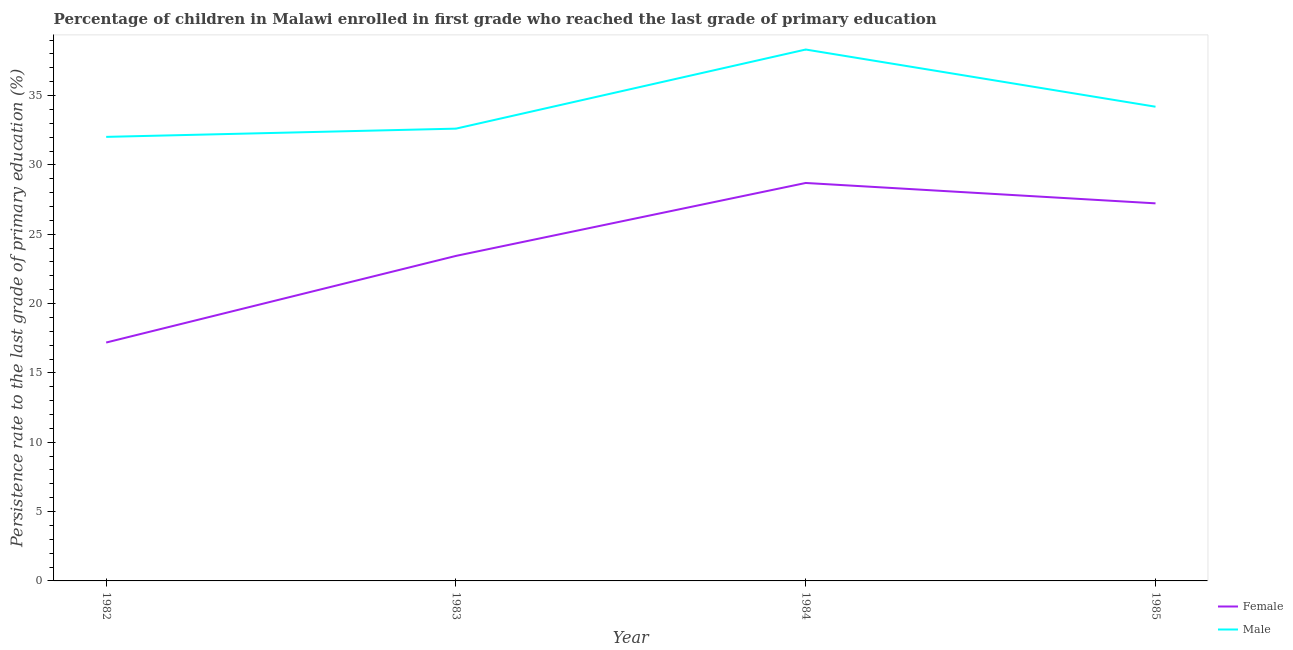Does the line corresponding to persistence rate of male students intersect with the line corresponding to persistence rate of female students?
Your response must be concise. No. Is the number of lines equal to the number of legend labels?
Offer a terse response. Yes. What is the persistence rate of female students in 1982?
Provide a succinct answer. 17.19. Across all years, what is the maximum persistence rate of male students?
Keep it short and to the point. 38.32. Across all years, what is the minimum persistence rate of female students?
Offer a very short reply. 17.19. In which year was the persistence rate of female students minimum?
Give a very brief answer. 1982. What is the total persistence rate of male students in the graph?
Your response must be concise. 137.15. What is the difference between the persistence rate of female students in 1982 and that in 1984?
Make the answer very short. -11.51. What is the difference between the persistence rate of female students in 1982 and the persistence rate of male students in 1984?
Make the answer very short. -21.13. What is the average persistence rate of female students per year?
Provide a short and direct response. 24.14. In the year 1983, what is the difference between the persistence rate of male students and persistence rate of female students?
Your response must be concise. 9.18. In how many years, is the persistence rate of male students greater than 19 %?
Give a very brief answer. 4. What is the ratio of the persistence rate of male students in 1983 to that in 1985?
Provide a short and direct response. 0.95. Is the persistence rate of female students in 1983 less than that in 1985?
Your response must be concise. Yes. Is the difference between the persistence rate of female students in 1984 and 1985 greater than the difference between the persistence rate of male students in 1984 and 1985?
Ensure brevity in your answer.  No. What is the difference between the highest and the second highest persistence rate of female students?
Ensure brevity in your answer.  1.47. What is the difference between the highest and the lowest persistence rate of female students?
Make the answer very short. 11.51. Is the sum of the persistence rate of female students in 1982 and 1985 greater than the maximum persistence rate of male students across all years?
Your response must be concise. Yes. How many years are there in the graph?
Ensure brevity in your answer.  4. What is the difference between two consecutive major ticks on the Y-axis?
Your answer should be compact. 5. Are the values on the major ticks of Y-axis written in scientific E-notation?
Give a very brief answer. No. Does the graph contain any zero values?
Keep it short and to the point. No. Does the graph contain grids?
Your response must be concise. No. How many legend labels are there?
Give a very brief answer. 2. How are the legend labels stacked?
Offer a terse response. Vertical. What is the title of the graph?
Provide a short and direct response. Percentage of children in Malawi enrolled in first grade who reached the last grade of primary education. Does "Current education expenditure" appear as one of the legend labels in the graph?
Keep it short and to the point. No. What is the label or title of the Y-axis?
Make the answer very short. Persistence rate to the last grade of primary education (%). What is the Persistence rate to the last grade of primary education (%) of Female in 1982?
Your answer should be very brief. 17.19. What is the Persistence rate to the last grade of primary education (%) of Male in 1982?
Your answer should be very brief. 32.02. What is the Persistence rate to the last grade of primary education (%) in Female in 1983?
Ensure brevity in your answer.  23.44. What is the Persistence rate to the last grade of primary education (%) in Male in 1983?
Give a very brief answer. 32.62. What is the Persistence rate to the last grade of primary education (%) in Female in 1984?
Give a very brief answer. 28.7. What is the Persistence rate to the last grade of primary education (%) in Male in 1984?
Provide a succinct answer. 38.32. What is the Persistence rate to the last grade of primary education (%) of Female in 1985?
Your answer should be compact. 27.23. What is the Persistence rate to the last grade of primary education (%) in Male in 1985?
Provide a succinct answer. 34.2. Across all years, what is the maximum Persistence rate to the last grade of primary education (%) of Female?
Your response must be concise. 28.7. Across all years, what is the maximum Persistence rate to the last grade of primary education (%) in Male?
Provide a short and direct response. 38.32. Across all years, what is the minimum Persistence rate to the last grade of primary education (%) in Female?
Provide a short and direct response. 17.19. Across all years, what is the minimum Persistence rate to the last grade of primary education (%) in Male?
Offer a terse response. 32.02. What is the total Persistence rate to the last grade of primary education (%) of Female in the graph?
Offer a very short reply. 96.55. What is the total Persistence rate to the last grade of primary education (%) in Male in the graph?
Offer a terse response. 137.15. What is the difference between the Persistence rate to the last grade of primary education (%) in Female in 1982 and that in 1983?
Make the answer very short. -6.25. What is the difference between the Persistence rate to the last grade of primary education (%) in Male in 1982 and that in 1983?
Make the answer very short. -0.59. What is the difference between the Persistence rate to the last grade of primary education (%) of Female in 1982 and that in 1984?
Your answer should be compact. -11.51. What is the difference between the Persistence rate to the last grade of primary education (%) of Male in 1982 and that in 1984?
Your answer should be very brief. -6.3. What is the difference between the Persistence rate to the last grade of primary education (%) of Female in 1982 and that in 1985?
Provide a succinct answer. -10.04. What is the difference between the Persistence rate to the last grade of primary education (%) in Male in 1982 and that in 1985?
Ensure brevity in your answer.  -2.17. What is the difference between the Persistence rate to the last grade of primary education (%) of Female in 1983 and that in 1984?
Keep it short and to the point. -5.26. What is the difference between the Persistence rate to the last grade of primary education (%) in Male in 1983 and that in 1984?
Your answer should be very brief. -5.71. What is the difference between the Persistence rate to the last grade of primary education (%) in Female in 1983 and that in 1985?
Your response must be concise. -3.79. What is the difference between the Persistence rate to the last grade of primary education (%) in Male in 1983 and that in 1985?
Your answer should be compact. -1.58. What is the difference between the Persistence rate to the last grade of primary education (%) in Female in 1984 and that in 1985?
Keep it short and to the point. 1.47. What is the difference between the Persistence rate to the last grade of primary education (%) of Male in 1984 and that in 1985?
Offer a terse response. 4.12. What is the difference between the Persistence rate to the last grade of primary education (%) in Female in 1982 and the Persistence rate to the last grade of primary education (%) in Male in 1983?
Keep it short and to the point. -15.42. What is the difference between the Persistence rate to the last grade of primary education (%) in Female in 1982 and the Persistence rate to the last grade of primary education (%) in Male in 1984?
Your response must be concise. -21.13. What is the difference between the Persistence rate to the last grade of primary education (%) of Female in 1982 and the Persistence rate to the last grade of primary education (%) of Male in 1985?
Make the answer very short. -17. What is the difference between the Persistence rate to the last grade of primary education (%) in Female in 1983 and the Persistence rate to the last grade of primary education (%) in Male in 1984?
Provide a short and direct response. -14.88. What is the difference between the Persistence rate to the last grade of primary education (%) of Female in 1983 and the Persistence rate to the last grade of primary education (%) of Male in 1985?
Your answer should be compact. -10.76. What is the difference between the Persistence rate to the last grade of primary education (%) of Female in 1984 and the Persistence rate to the last grade of primary education (%) of Male in 1985?
Offer a very short reply. -5.5. What is the average Persistence rate to the last grade of primary education (%) in Female per year?
Give a very brief answer. 24.14. What is the average Persistence rate to the last grade of primary education (%) of Male per year?
Provide a short and direct response. 34.29. In the year 1982, what is the difference between the Persistence rate to the last grade of primary education (%) of Female and Persistence rate to the last grade of primary education (%) of Male?
Your answer should be compact. -14.83. In the year 1983, what is the difference between the Persistence rate to the last grade of primary education (%) in Female and Persistence rate to the last grade of primary education (%) in Male?
Make the answer very short. -9.18. In the year 1984, what is the difference between the Persistence rate to the last grade of primary education (%) in Female and Persistence rate to the last grade of primary education (%) in Male?
Your answer should be very brief. -9.62. In the year 1985, what is the difference between the Persistence rate to the last grade of primary education (%) of Female and Persistence rate to the last grade of primary education (%) of Male?
Make the answer very short. -6.97. What is the ratio of the Persistence rate to the last grade of primary education (%) in Female in 1982 to that in 1983?
Ensure brevity in your answer.  0.73. What is the ratio of the Persistence rate to the last grade of primary education (%) in Male in 1982 to that in 1983?
Keep it short and to the point. 0.98. What is the ratio of the Persistence rate to the last grade of primary education (%) of Female in 1982 to that in 1984?
Provide a succinct answer. 0.6. What is the ratio of the Persistence rate to the last grade of primary education (%) in Male in 1982 to that in 1984?
Provide a short and direct response. 0.84. What is the ratio of the Persistence rate to the last grade of primary education (%) in Female in 1982 to that in 1985?
Give a very brief answer. 0.63. What is the ratio of the Persistence rate to the last grade of primary education (%) in Male in 1982 to that in 1985?
Provide a short and direct response. 0.94. What is the ratio of the Persistence rate to the last grade of primary education (%) of Female in 1983 to that in 1984?
Offer a terse response. 0.82. What is the ratio of the Persistence rate to the last grade of primary education (%) in Male in 1983 to that in 1984?
Offer a terse response. 0.85. What is the ratio of the Persistence rate to the last grade of primary education (%) of Female in 1983 to that in 1985?
Your response must be concise. 0.86. What is the ratio of the Persistence rate to the last grade of primary education (%) of Male in 1983 to that in 1985?
Keep it short and to the point. 0.95. What is the ratio of the Persistence rate to the last grade of primary education (%) of Female in 1984 to that in 1985?
Provide a short and direct response. 1.05. What is the ratio of the Persistence rate to the last grade of primary education (%) of Male in 1984 to that in 1985?
Your response must be concise. 1.12. What is the difference between the highest and the second highest Persistence rate to the last grade of primary education (%) in Female?
Your answer should be very brief. 1.47. What is the difference between the highest and the second highest Persistence rate to the last grade of primary education (%) in Male?
Make the answer very short. 4.12. What is the difference between the highest and the lowest Persistence rate to the last grade of primary education (%) in Female?
Give a very brief answer. 11.51. What is the difference between the highest and the lowest Persistence rate to the last grade of primary education (%) in Male?
Give a very brief answer. 6.3. 